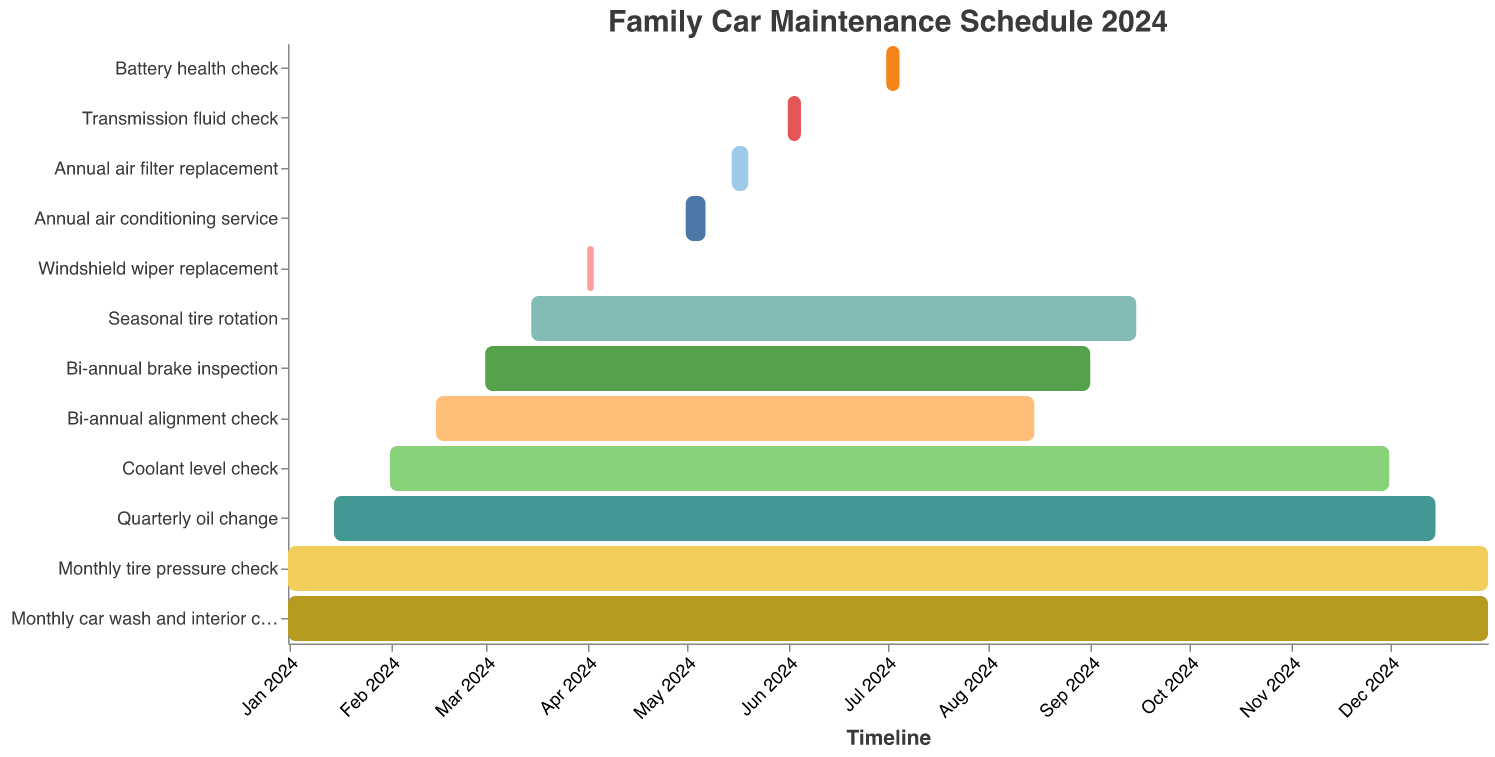What is the title of the Gantt chart? The title of a Gantt chart is usually found at the top of the chart. In this case, it's clearly labeled at the top with a larger font size.
Answer: Family Car Maintenance Schedule 2024 How frequently is the tire pressure checked? By looking at the Gantt chart bars, you can see the task "Monthly tire pressure check" spans the entire year from January to December.
Answer: Monthly What tasks are performed in July? Identify the bars corresponding to July on the timeline axis and check the tasks listed. Two tasks fall within July: "Battery health check" and "Monthly tire pressure check."
Answer: Battery health check, Monthly tire pressure check When does the annual air conditioner service start and end? Locate the bar labeled "Annual air conditioning service" and check the start and end dates on the timeline axis. The service starts on May 1 and ends on May 7.
Answer: May 1 to May 7 Which task has the shortest duration? Compare the durations of all bars visually; the shortest bar indicates the shortest duration. The "Windshield wiper replacement" task has the shortest duration, spanning only three days from April 1 to April 3.
Answer: Windshield wiper replacement Does the coolant level check span the entire year? Look at the bar for "Coolant level check" to determine its start and end dates. It begins on February 1 and ends on December 1, not covering January.
Answer: No How many times are the brakes inspected throughout the year? Refer to the bar for "Bi-annual brake inspection" and note both the start and end dates for each span. The inspection occurs twice: from March 1 to September 1.
Answer: Two times Which task overlaps with the quarterly oil change at any point in the year? Compare the timeline of the "Quarterly oil change" with other tasks. The task "Monthly tire pressure check" and "Monthly car wash and interior cleaning" continuously overlap with it.
Answer: Monthly tire pressure check, Monthly car wash and interior cleaning What is the total duration for the air filter replacement task? The "Annual air filter replacement" bar starts on May 15 and ends on May 20. Calculate the total duration by subtracting the start date from the end date.
Answer: 5 days 